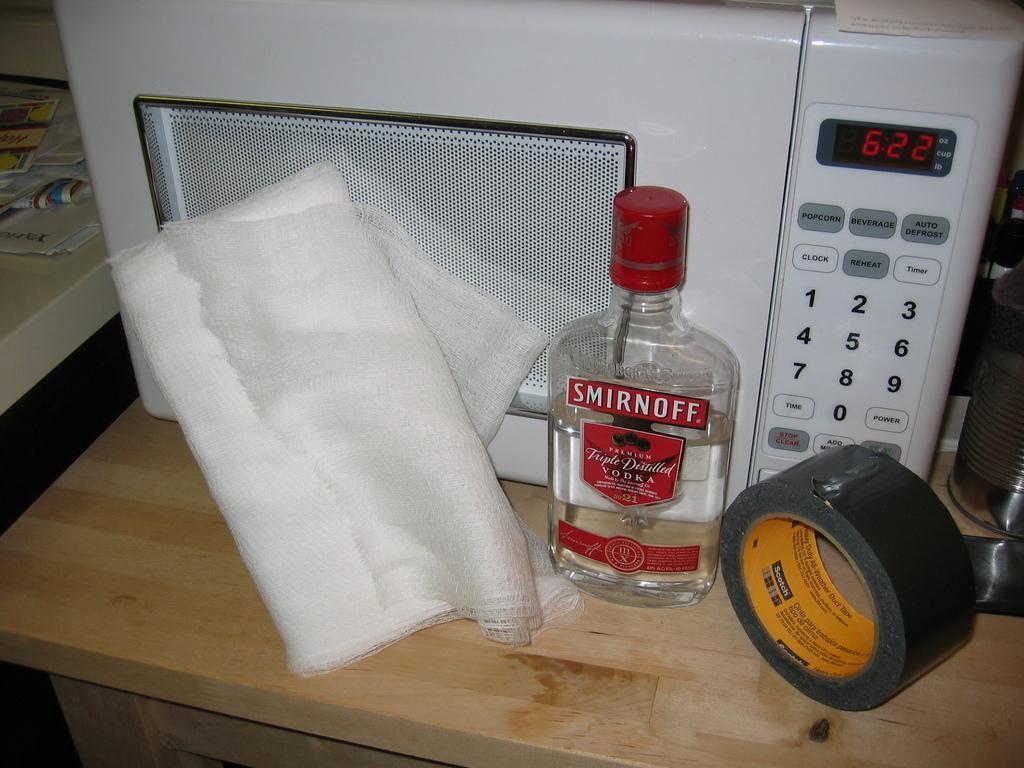In one or two sentences, can you explain what this image depicts? In this picture we see a timer ,a bottle and cotton over here at the right side bottom tape. 